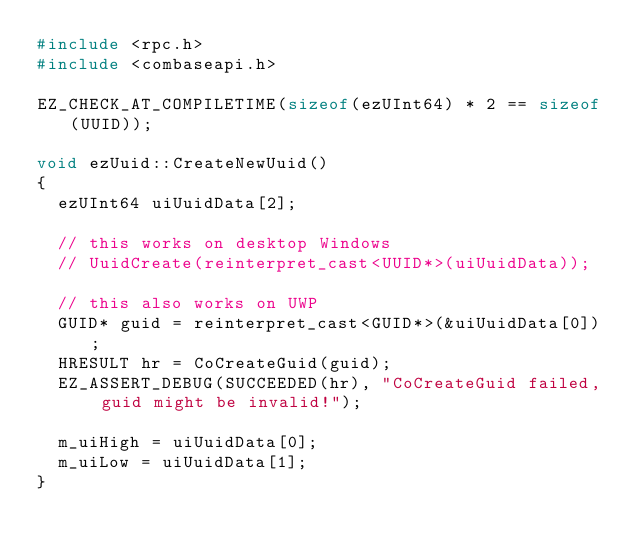<code> <loc_0><loc_0><loc_500><loc_500><_C_>#include <rpc.h>
#include <combaseapi.h>

EZ_CHECK_AT_COMPILETIME(sizeof(ezUInt64) * 2 == sizeof(UUID));

void ezUuid::CreateNewUuid()
{
  ezUInt64 uiUuidData[2];

  // this works on desktop Windows
  // UuidCreate(reinterpret_cast<UUID*>(uiUuidData));

  // this also works on UWP
  GUID* guid = reinterpret_cast<GUID*>(&uiUuidData[0]);
  HRESULT hr = CoCreateGuid(guid);
  EZ_ASSERT_DEBUG(SUCCEEDED(hr), "CoCreateGuid failed, guid might be invalid!");

  m_uiHigh = uiUuidData[0];
  m_uiLow = uiUuidData[1];
}

</code> 